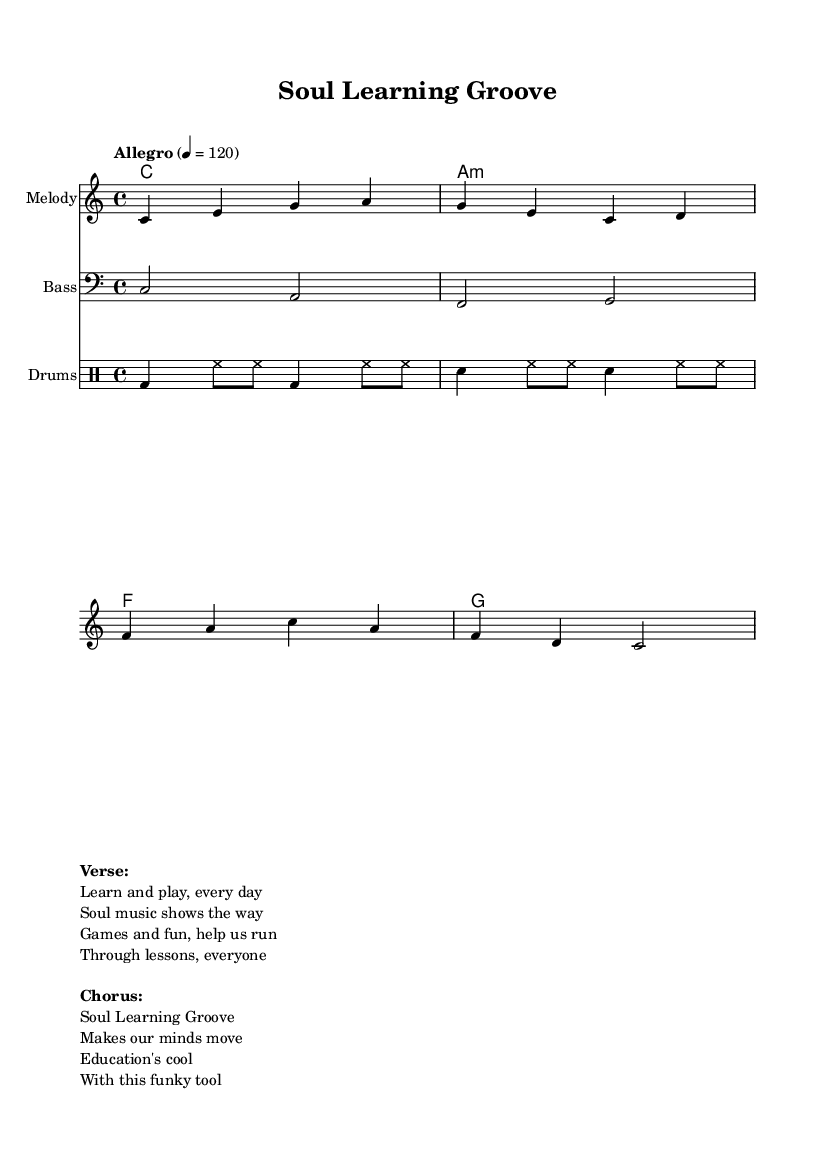What is the key signature of this music? The key signature indicated in the global section of the sheet music is C major, which contains no sharps or flats.
Answer: C major What is the time signature of this music? The time signature is found in the global section and shows that there are four beats per measure. It is noted as 4/4, which is a common time signature.
Answer: 4/4 What is the tempo marking for this piece? The tempo marking is located in the global section, where it specifies "Allegro" at a tempo of 120 beats per minute, indicating a fast and lively pace.
Answer: Allegro 4 = 120 How many measures are in the melody? By counting the measures in the melody part, there are a total of four measures present in the melody section.
Answer: 4 What instruments are included in this piece? The instruments are specified in different staffs; they include a Melody staff, a Bass staff, and a Drum staff.
Answer: Melody, Bass, Drums What is the main focus of the lyrics provided? The lyrics emphasize the fun and educational aspect of using music and games for learning, showcasing the connection between soul music and classroom activities.
Answer: Soul Learning Groove In which clef is the bass line written? The bass line is indicated to be in the bass clef, which is typically used for lower-pitched instruments and voices.
Answer: Bass clef 